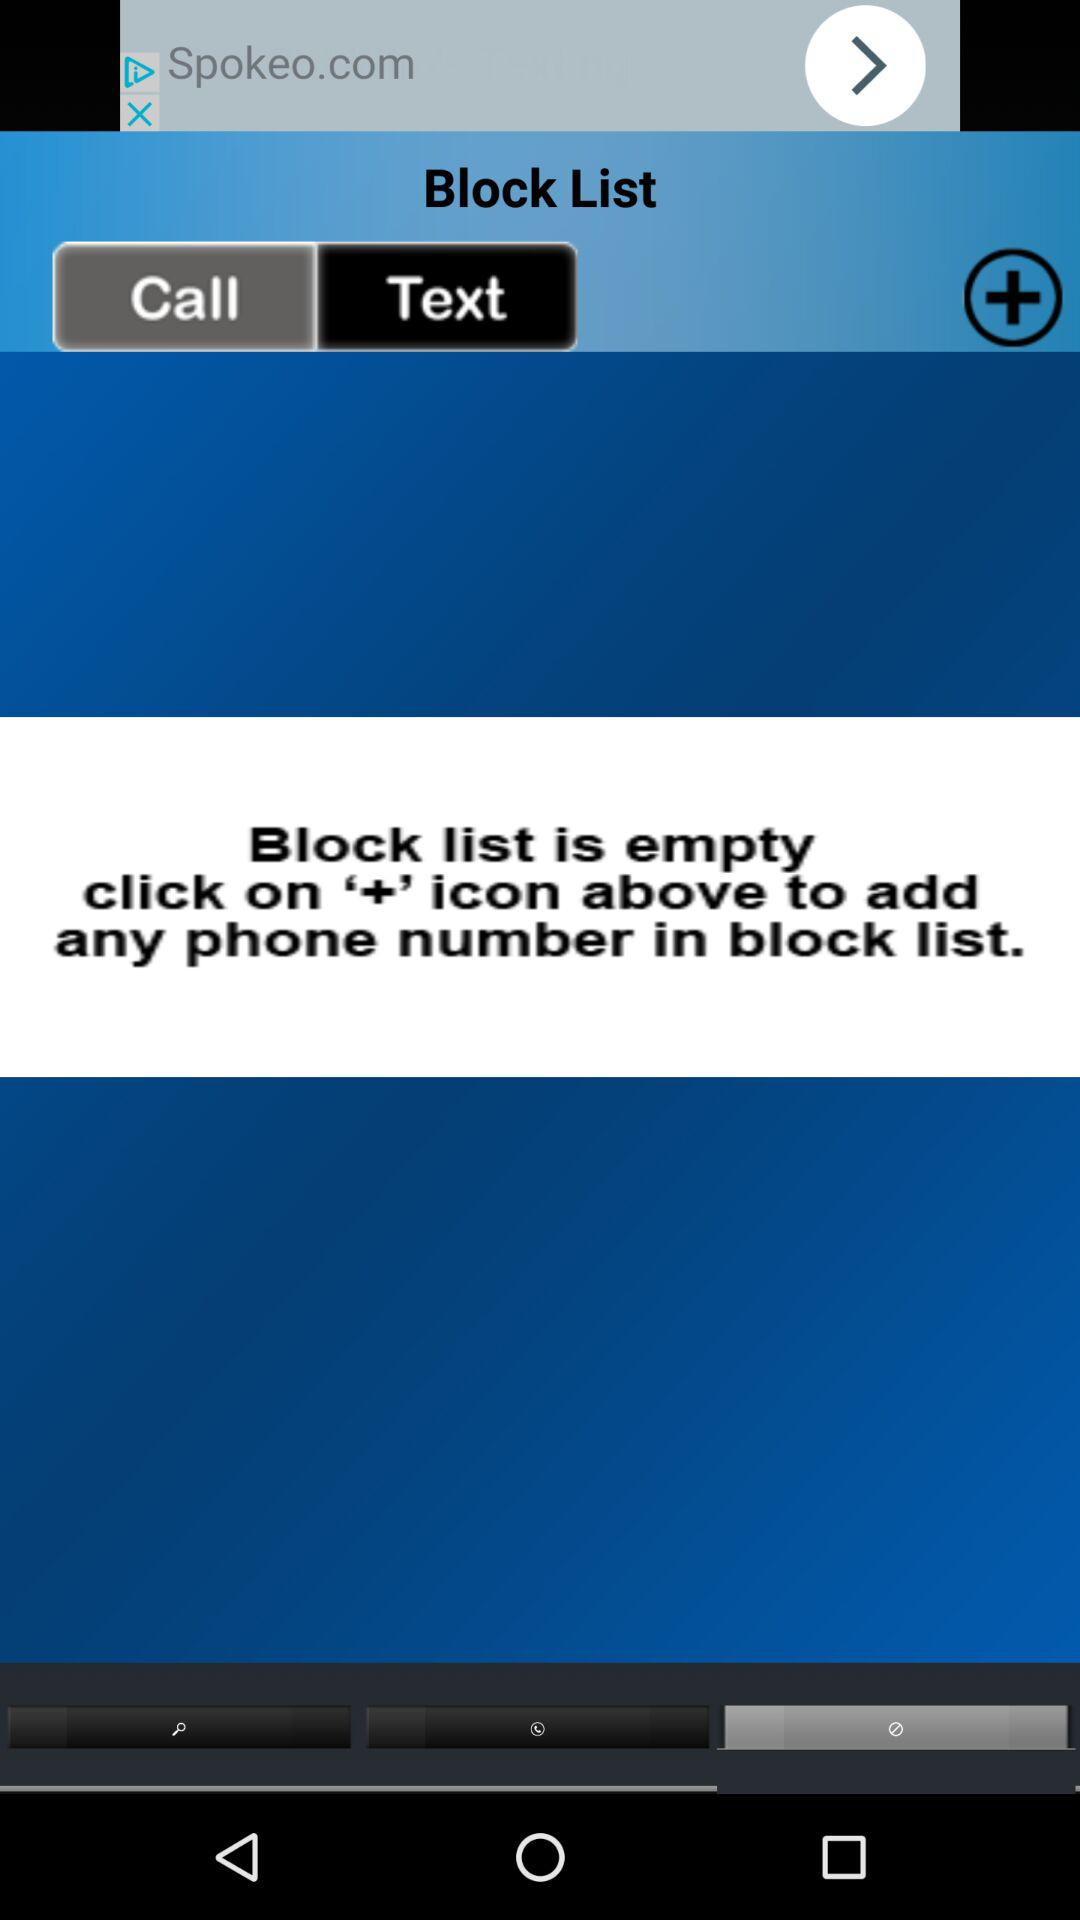Is the block list empty? The block list is empty. 